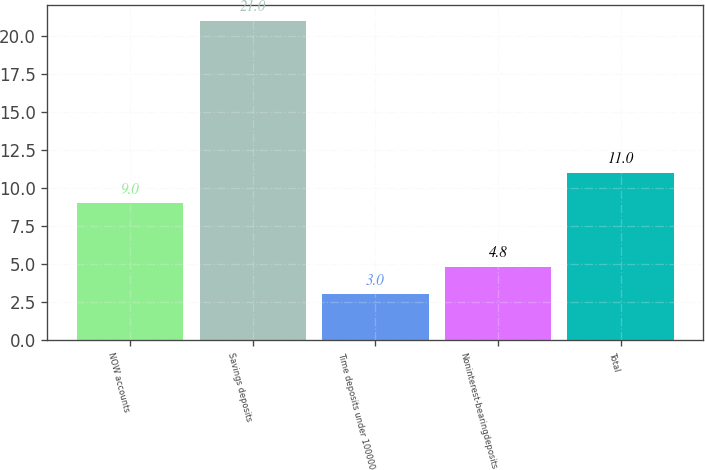Convert chart. <chart><loc_0><loc_0><loc_500><loc_500><bar_chart><fcel>NOW accounts<fcel>Savings deposits<fcel>Time deposits under 100000<fcel>Noninterest-bearingdeposits<fcel>Total<nl><fcel>9<fcel>21<fcel>3<fcel>4.8<fcel>11<nl></chart> 